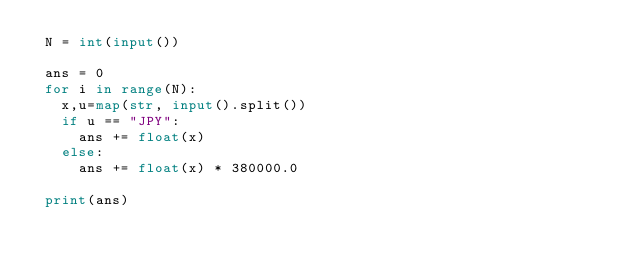<code> <loc_0><loc_0><loc_500><loc_500><_Python_> N = int(input())

 ans = 0
 for i in range(N):
   x,u=map(str, input().split())
   if u == "JPY":
     ans += float(x)
   else:
     ans += float(x) * 380000.0

 print(ans)
</code> 